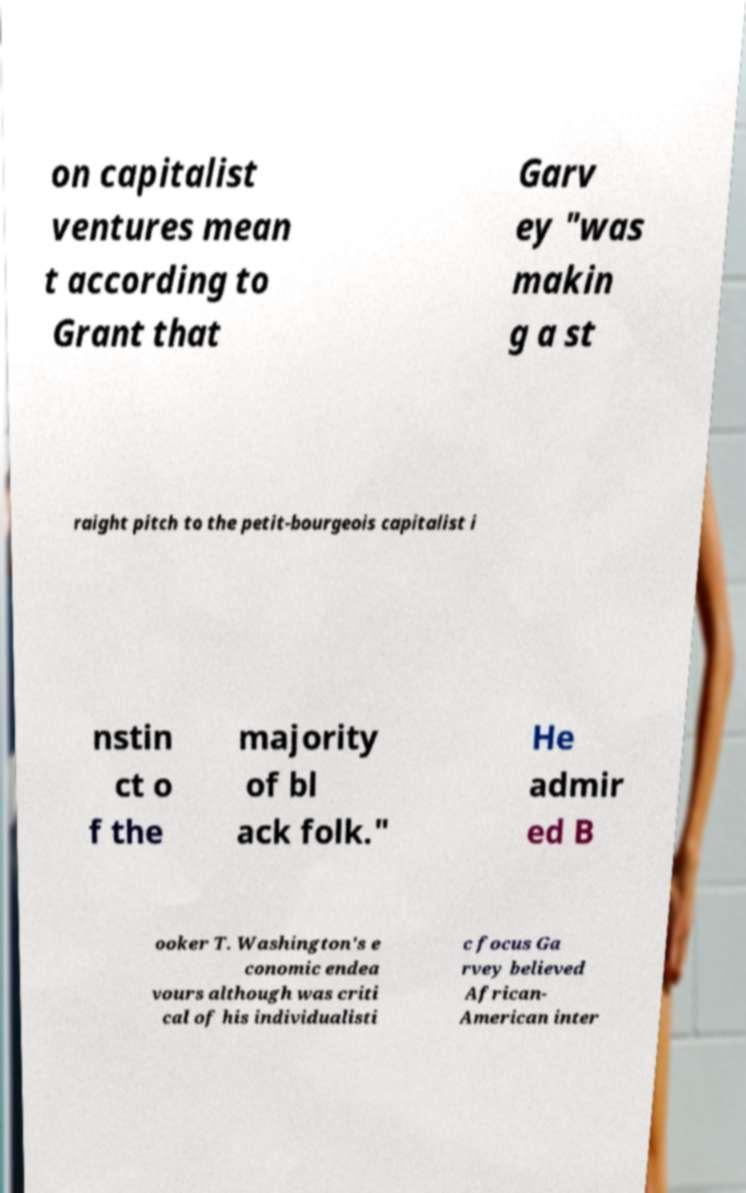Could you assist in decoding the text presented in this image and type it out clearly? on capitalist ventures mean t according to Grant that Garv ey "was makin g a st raight pitch to the petit-bourgeois capitalist i nstin ct o f the majority of bl ack folk." He admir ed B ooker T. Washington's e conomic endea vours although was criti cal of his individualisti c focus Ga rvey believed African- American inter 